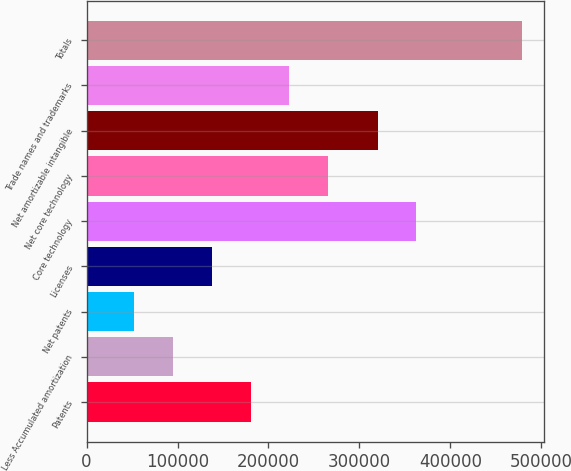<chart> <loc_0><loc_0><loc_500><loc_500><bar_chart><fcel>Patents<fcel>Less Accumulated amortization<fcel>Net patents<fcel>Licenses<fcel>Core technology<fcel>Net core technology<fcel>Net amortizable intangible<fcel>Trade names and trademarks<fcel>Totals<nl><fcel>180389<fcel>95011.6<fcel>52323<fcel>137700<fcel>362733<fcel>265766<fcel>320044<fcel>223077<fcel>479209<nl></chart> 